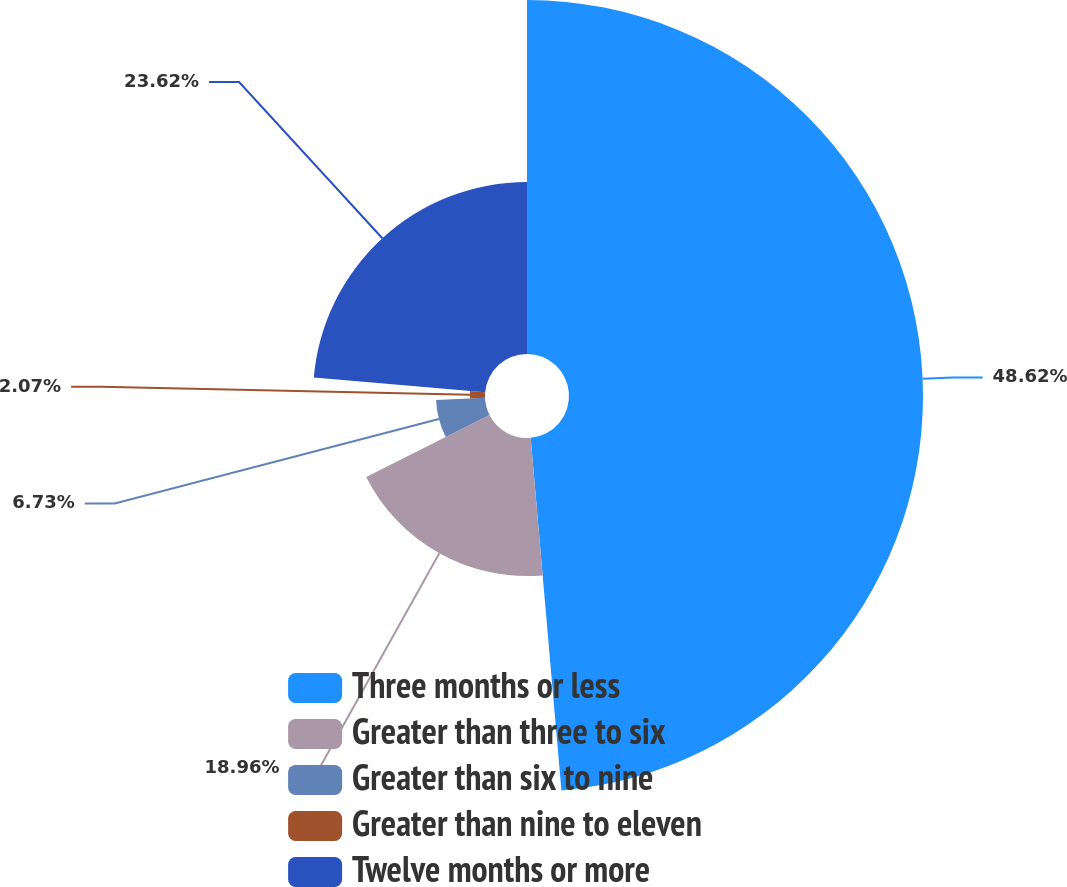<chart> <loc_0><loc_0><loc_500><loc_500><pie_chart><fcel>Three months or less<fcel>Greater than three to six<fcel>Greater than six to nine<fcel>Greater than nine to eleven<fcel>Twelve months or more<nl><fcel>48.61%<fcel>18.96%<fcel>6.73%<fcel>2.07%<fcel>23.62%<nl></chart> 